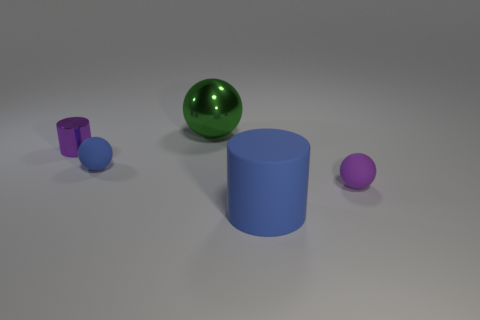Subtract all tiny blue rubber spheres. How many spheres are left? 2 Add 4 big metallic things. How many objects exist? 9 Subtract all purple cylinders. How many cylinders are left? 1 Subtract all spheres. How many objects are left? 2 Subtract 1 cylinders. How many cylinders are left? 1 Add 5 small purple metal cylinders. How many small purple metal cylinders exist? 6 Subtract 0 cyan spheres. How many objects are left? 5 Subtract all green spheres. Subtract all gray blocks. How many spheres are left? 2 Subtract all red cylinders. How many gray balls are left? 0 Subtract all large brown metallic objects. Subtract all spheres. How many objects are left? 2 